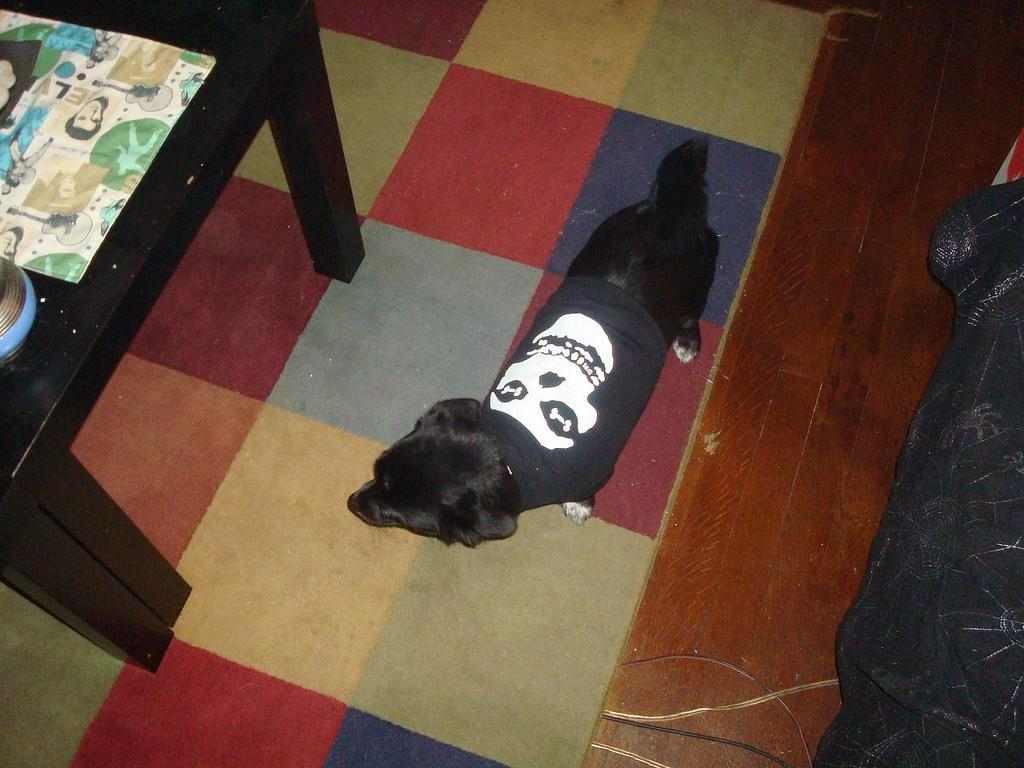What type of animal is in the image? There is a dog in the image. What is the dog wearing? The dog is wearing a t-shirt. Where is the dog located in the image? The dog is on the floor. What other furniture or objects can be seen in the image? There is a table in the image. What side of the dog is feeling shame in the image? There is no indication in the image that the dog is feeling shame or that one side of the dog is more affected than the other. 